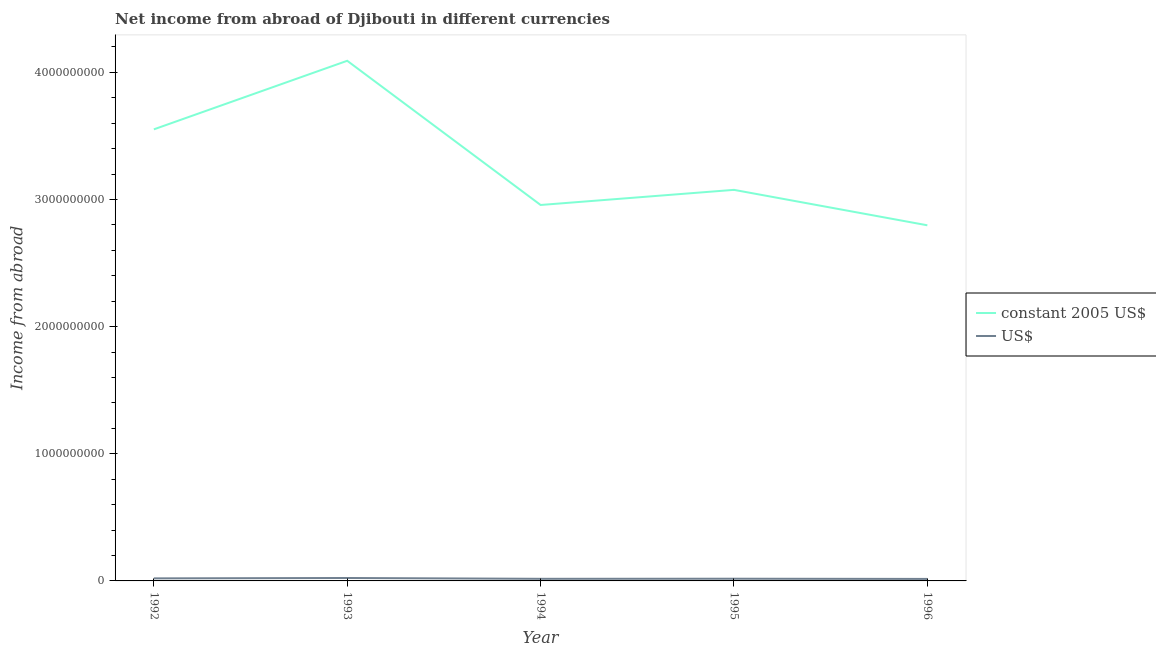How many different coloured lines are there?
Your answer should be very brief. 2. Does the line corresponding to income from abroad in constant 2005 us$ intersect with the line corresponding to income from abroad in us$?
Your answer should be compact. No. Is the number of lines equal to the number of legend labels?
Your answer should be very brief. Yes. What is the income from abroad in us$ in 1994?
Provide a short and direct response. 1.66e+07. Across all years, what is the maximum income from abroad in constant 2005 us$?
Offer a terse response. 4.09e+09. Across all years, what is the minimum income from abroad in constant 2005 us$?
Your response must be concise. 2.80e+09. In which year was the income from abroad in us$ maximum?
Provide a short and direct response. 1993. What is the total income from abroad in constant 2005 us$ in the graph?
Keep it short and to the point. 1.65e+1. What is the difference between the income from abroad in constant 2005 us$ in 1993 and that in 1995?
Offer a very short reply. 1.02e+09. What is the difference between the income from abroad in us$ in 1994 and the income from abroad in constant 2005 us$ in 1995?
Ensure brevity in your answer.  -3.06e+09. What is the average income from abroad in us$ per year?
Offer a terse response. 1.85e+07. In the year 1996, what is the difference between the income from abroad in constant 2005 us$ and income from abroad in us$?
Keep it short and to the point. 2.78e+09. In how many years, is the income from abroad in us$ greater than 3600000000 units?
Your response must be concise. 0. What is the ratio of the income from abroad in us$ in 1993 to that in 1996?
Give a very brief answer. 1.46. Is the difference between the income from abroad in constant 2005 us$ in 1992 and 1995 greater than the difference between the income from abroad in us$ in 1992 and 1995?
Keep it short and to the point. Yes. What is the difference between the highest and the second highest income from abroad in us$?
Your response must be concise. 3.04e+06. What is the difference between the highest and the lowest income from abroad in constant 2005 us$?
Make the answer very short. 1.29e+09. Is the income from abroad in us$ strictly greater than the income from abroad in constant 2005 us$ over the years?
Ensure brevity in your answer.  No. What is the difference between two consecutive major ticks on the Y-axis?
Give a very brief answer. 1.00e+09. Does the graph contain any zero values?
Offer a very short reply. No. How many legend labels are there?
Your response must be concise. 2. How are the legend labels stacked?
Your answer should be compact. Vertical. What is the title of the graph?
Provide a short and direct response. Net income from abroad of Djibouti in different currencies. What is the label or title of the Y-axis?
Your answer should be very brief. Income from abroad. What is the Income from abroad of constant 2005 US$ in 1992?
Provide a succinct answer. 3.55e+09. What is the Income from abroad of US$ in 1992?
Your answer should be very brief. 2.00e+07. What is the Income from abroad of constant 2005 US$ in 1993?
Your answer should be compact. 4.09e+09. What is the Income from abroad of US$ in 1993?
Make the answer very short. 2.30e+07. What is the Income from abroad of constant 2005 US$ in 1994?
Offer a very short reply. 2.96e+09. What is the Income from abroad in US$ in 1994?
Keep it short and to the point. 1.66e+07. What is the Income from abroad of constant 2005 US$ in 1995?
Keep it short and to the point. 3.08e+09. What is the Income from abroad of US$ in 1995?
Provide a short and direct response. 1.73e+07. What is the Income from abroad in constant 2005 US$ in 1996?
Offer a terse response. 2.80e+09. What is the Income from abroad in US$ in 1996?
Your answer should be very brief. 1.57e+07. Across all years, what is the maximum Income from abroad in constant 2005 US$?
Keep it short and to the point. 4.09e+09. Across all years, what is the maximum Income from abroad of US$?
Your answer should be compact. 2.30e+07. Across all years, what is the minimum Income from abroad of constant 2005 US$?
Offer a terse response. 2.80e+09. Across all years, what is the minimum Income from abroad in US$?
Make the answer very short. 1.57e+07. What is the total Income from abroad in constant 2005 US$ in the graph?
Provide a short and direct response. 1.65e+1. What is the total Income from abroad in US$ in the graph?
Your response must be concise. 9.27e+07. What is the difference between the Income from abroad of constant 2005 US$ in 1992 and that in 1993?
Ensure brevity in your answer.  -5.39e+08. What is the difference between the Income from abroad of US$ in 1992 and that in 1993?
Provide a short and direct response. -3.04e+06. What is the difference between the Income from abroad of constant 2005 US$ in 1992 and that in 1994?
Offer a very short reply. 5.95e+08. What is the difference between the Income from abroad of US$ in 1992 and that in 1994?
Your response must be concise. 3.35e+06. What is the difference between the Income from abroad in constant 2005 US$ in 1992 and that in 1995?
Offer a very short reply. 4.76e+08. What is the difference between the Income from abroad in US$ in 1992 and that in 1995?
Your answer should be compact. 2.68e+06. What is the difference between the Income from abroad of constant 2005 US$ in 1992 and that in 1996?
Offer a very short reply. 7.55e+08. What is the difference between the Income from abroad in US$ in 1992 and that in 1996?
Provide a succinct answer. 4.25e+06. What is the difference between the Income from abroad of constant 2005 US$ in 1993 and that in 1994?
Your answer should be compact. 1.13e+09. What is the difference between the Income from abroad in US$ in 1993 and that in 1994?
Your answer should be compact. 6.38e+06. What is the difference between the Income from abroad of constant 2005 US$ in 1993 and that in 1995?
Make the answer very short. 1.02e+09. What is the difference between the Income from abroad of US$ in 1993 and that in 1995?
Give a very brief answer. 5.71e+06. What is the difference between the Income from abroad in constant 2005 US$ in 1993 and that in 1996?
Your answer should be very brief. 1.29e+09. What is the difference between the Income from abroad of US$ in 1993 and that in 1996?
Keep it short and to the point. 7.28e+06. What is the difference between the Income from abroad of constant 2005 US$ in 1994 and that in 1995?
Keep it short and to the point. -1.19e+08. What is the difference between the Income from abroad of US$ in 1994 and that in 1995?
Provide a short and direct response. -6.69e+05. What is the difference between the Income from abroad of constant 2005 US$ in 1994 and that in 1996?
Your answer should be compact. 1.60e+08. What is the difference between the Income from abroad in US$ in 1994 and that in 1996?
Your answer should be very brief. 8.99e+05. What is the difference between the Income from abroad in constant 2005 US$ in 1995 and that in 1996?
Your answer should be compact. 2.79e+08. What is the difference between the Income from abroad of US$ in 1995 and that in 1996?
Your answer should be very brief. 1.57e+06. What is the difference between the Income from abroad of constant 2005 US$ in 1992 and the Income from abroad of US$ in 1993?
Provide a short and direct response. 3.53e+09. What is the difference between the Income from abroad in constant 2005 US$ in 1992 and the Income from abroad in US$ in 1994?
Give a very brief answer. 3.54e+09. What is the difference between the Income from abroad in constant 2005 US$ in 1992 and the Income from abroad in US$ in 1995?
Your answer should be compact. 3.53e+09. What is the difference between the Income from abroad in constant 2005 US$ in 1992 and the Income from abroad in US$ in 1996?
Offer a terse response. 3.54e+09. What is the difference between the Income from abroad in constant 2005 US$ in 1993 and the Income from abroad in US$ in 1994?
Make the answer very short. 4.07e+09. What is the difference between the Income from abroad in constant 2005 US$ in 1993 and the Income from abroad in US$ in 1995?
Ensure brevity in your answer.  4.07e+09. What is the difference between the Income from abroad of constant 2005 US$ in 1993 and the Income from abroad of US$ in 1996?
Your response must be concise. 4.08e+09. What is the difference between the Income from abroad of constant 2005 US$ in 1994 and the Income from abroad of US$ in 1995?
Ensure brevity in your answer.  2.94e+09. What is the difference between the Income from abroad of constant 2005 US$ in 1994 and the Income from abroad of US$ in 1996?
Provide a short and direct response. 2.94e+09. What is the difference between the Income from abroad in constant 2005 US$ in 1995 and the Income from abroad in US$ in 1996?
Your response must be concise. 3.06e+09. What is the average Income from abroad of constant 2005 US$ per year?
Make the answer very short. 3.29e+09. What is the average Income from abroad of US$ per year?
Make the answer very short. 1.85e+07. In the year 1992, what is the difference between the Income from abroad of constant 2005 US$ and Income from abroad of US$?
Provide a succinct answer. 3.53e+09. In the year 1993, what is the difference between the Income from abroad of constant 2005 US$ and Income from abroad of US$?
Keep it short and to the point. 4.07e+09. In the year 1994, what is the difference between the Income from abroad of constant 2005 US$ and Income from abroad of US$?
Keep it short and to the point. 2.94e+09. In the year 1995, what is the difference between the Income from abroad of constant 2005 US$ and Income from abroad of US$?
Keep it short and to the point. 3.06e+09. In the year 1996, what is the difference between the Income from abroad in constant 2005 US$ and Income from abroad in US$?
Offer a terse response. 2.78e+09. What is the ratio of the Income from abroad of constant 2005 US$ in 1992 to that in 1993?
Provide a succinct answer. 0.87. What is the ratio of the Income from abroad in US$ in 1992 to that in 1993?
Give a very brief answer. 0.87. What is the ratio of the Income from abroad of constant 2005 US$ in 1992 to that in 1994?
Your response must be concise. 1.2. What is the ratio of the Income from abroad of US$ in 1992 to that in 1994?
Give a very brief answer. 1.2. What is the ratio of the Income from abroad of constant 2005 US$ in 1992 to that in 1995?
Your answer should be compact. 1.15. What is the ratio of the Income from abroad of US$ in 1992 to that in 1995?
Your response must be concise. 1.15. What is the ratio of the Income from abroad in constant 2005 US$ in 1992 to that in 1996?
Offer a very short reply. 1.27. What is the ratio of the Income from abroad of US$ in 1992 to that in 1996?
Your answer should be very brief. 1.27. What is the ratio of the Income from abroad in constant 2005 US$ in 1993 to that in 1994?
Your response must be concise. 1.38. What is the ratio of the Income from abroad of US$ in 1993 to that in 1994?
Provide a succinct answer. 1.38. What is the ratio of the Income from abroad of constant 2005 US$ in 1993 to that in 1995?
Make the answer very short. 1.33. What is the ratio of the Income from abroad in US$ in 1993 to that in 1995?
Keep it short and to the point. 1.33. What is the ratio of the Income from abroad in constant 2005 US$ in 1993 to that in 1996?
Give a very brief answer. 1.46. What is the ratio of the Income from abroad in US$ in 1993 to that in 1996?
Give a very brief answer. 1.46. What is the ratio of the Income from abroad in constant 2005 US$ in 1994 to that in 1995?
Offer a very short reply. 0.96. What is the ratio of the Income from abroad of US$ in 1994 to that in 1995?
Offer a terse response. 0.96. What is the ratio of the Income from abroad in constant 2005 US$ in 1994 to that in 1996?
Your answer should be very brief. 1.06. What is the ratio of the Income from abroad in US$ in 1994 to that in 1996?
Make the answer very short. 1.06. What is the ratio of the Income from abroad in constant 2005 US$ in 1995 to that in 1996?
Your response must be concise. 1.1. What is the ratio of the Income from abroad of US$ in 1995 to that in 1996?
Your answer should be very brief. 1.1. What is the difference between the highest and the second highest Income from abroad in constant 2005 US$?
Provide a short and direct response. 5.39e+08. What is the difference between the highest and the second highest Income from abroad of US$?
Make the answer very short. 3.04e+06. What is the difference between the highest and the lowest Income from abroad of constant 2005 US$?
Make the answer very short. 1.29e+09. What is the difference between the highest and the lowest Income from abroad of US$?
Offer a very short reply. 7.28e+06. 